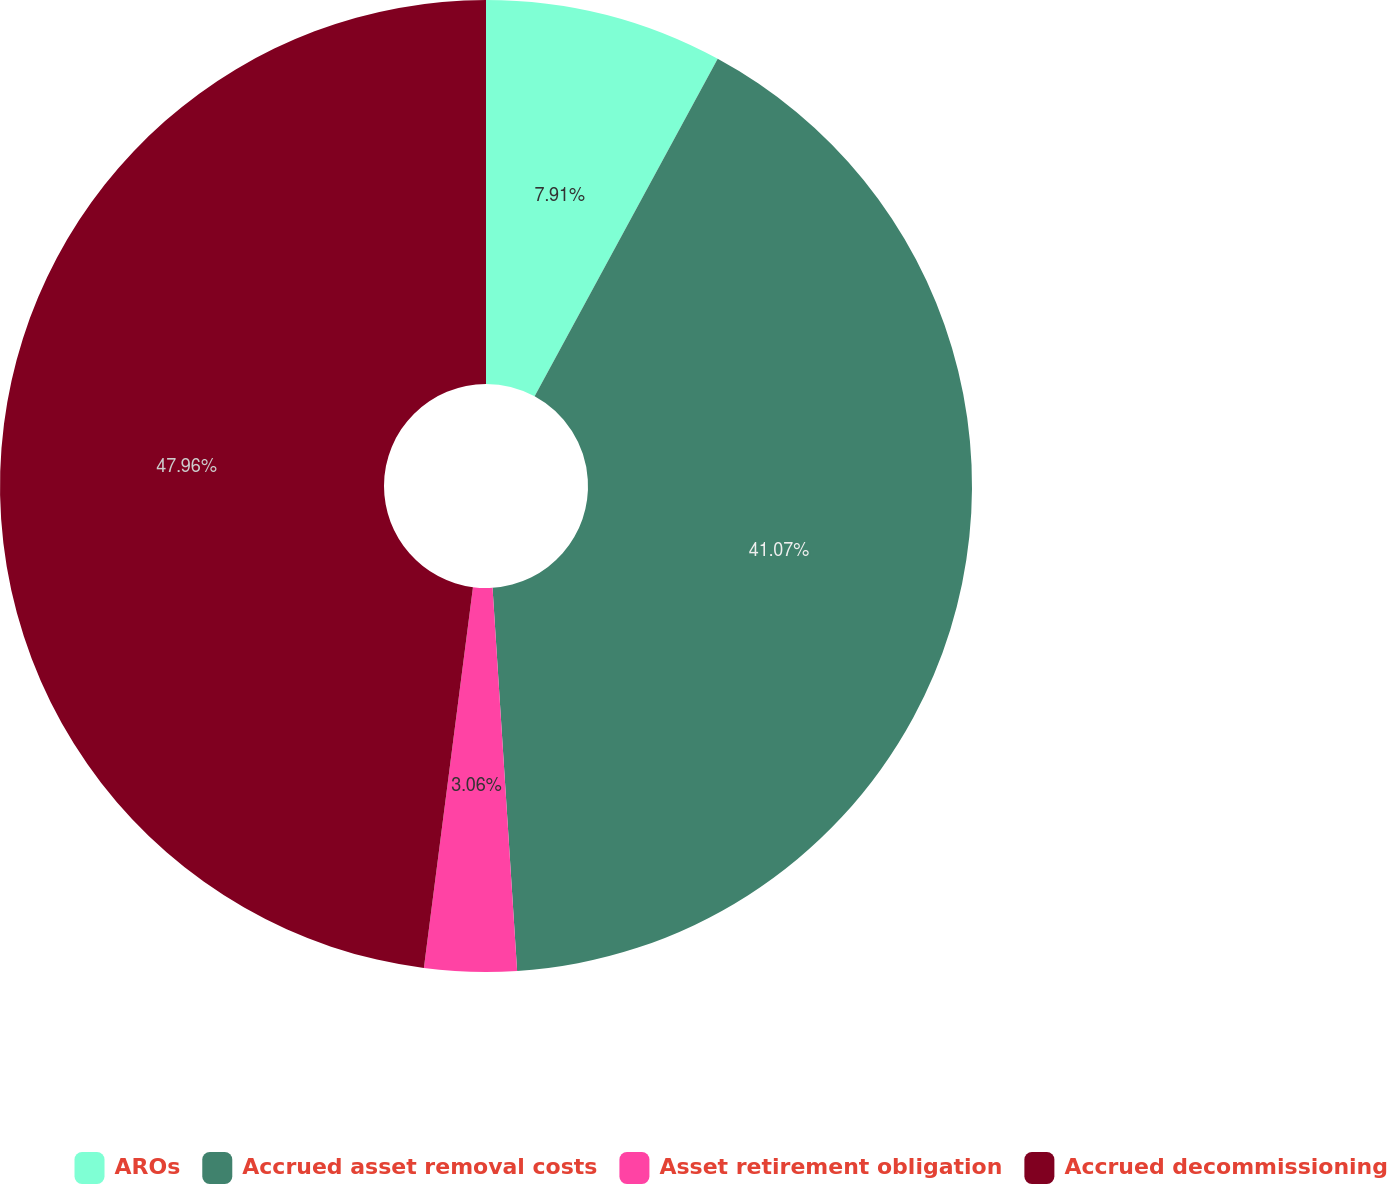Convert chart to OTSL. <chart><loc_0><loc_0><loc_500><loc_500><pie_chart><fcel>AROs<fcel>Accrued asset removal costs<fcel>Asset retirement obligation<fcel>Accrued decommissioning<nl><fcel>7.91%<fcel>41.07%<fcel>3.06%<fcel>47.96%<nl></chart> 